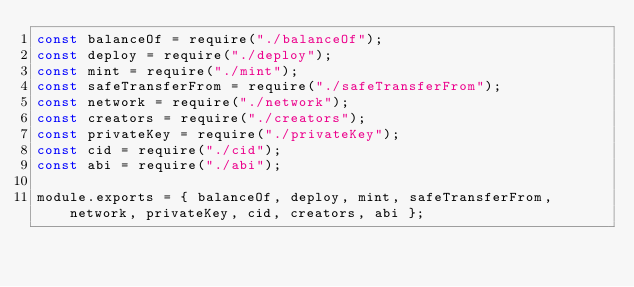Convert code to text. <code><loc_0><loc_0><loc_500><loc_500><_JavaScript_>const balanceOf = require("./balanceOf");
const deploy = require("./deploy");
const mint = require("./mint");
const safeTransferFrom = require("./safeTransferFrom");
const network = require("./network");
const creators = require("./creators");
const privateKey = require("./privateKey");
const cid = require("./cid");
const abi = require("./abi");

module.exports = { balanceOf, deploy, mint, safeTransferFrom, network, privateKey, cid, creators, abi };
</code> 